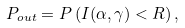Convert formula to latex. <formula><loc_0><loc_0><loc_500><loc_500>P _ { o u t } = P \left ( I ( \alpha , \gamma ) < R \right ) ,</formula> 